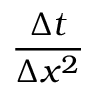Convert formula to latex. <formula><loc_0><loc_0><loc_500><loc_500>\frac { \Delta t } { \Delta x ^ { 2 } }</formula> 